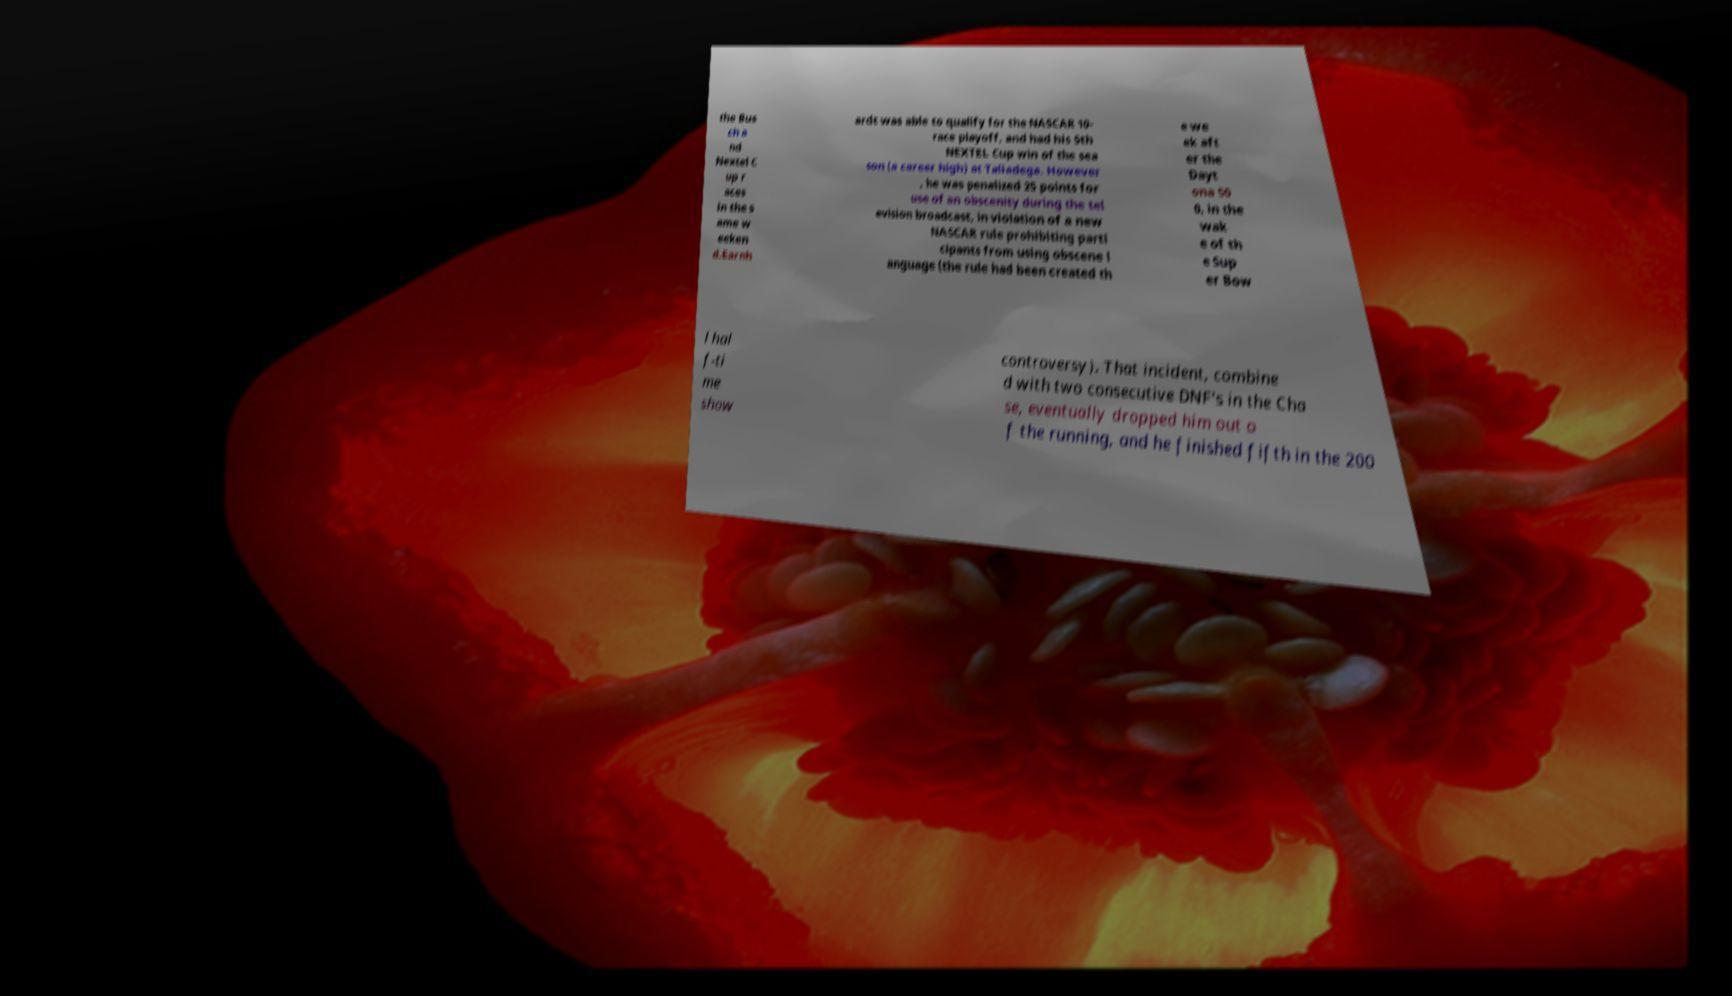Please read and relay the text visible in this image. What does it say? the Bus ch a nd Nextel C up r aces in the s ame w eeken d.Earnh ardt was able to qualify for the NASCAR 10- race playoff, and had his 5th NEXTEL Cup win of the sea son (a career high) at Talladega. However , he was penalized 25 points for use of an obscenity during the tel evision broadcast, in violation of a new NASCAR rule prohibiting parti cipants from using obscene l anguage (the rule had been created th e we ek aft er the Dayt ona 50 0, in the wak e of th e Sup er Bow l hal f-ti me show controversy). That incident, combine d with two consecutive DNF's in the Cha se, eventually dropped him out o f the running, and he finished fifth in the 200 